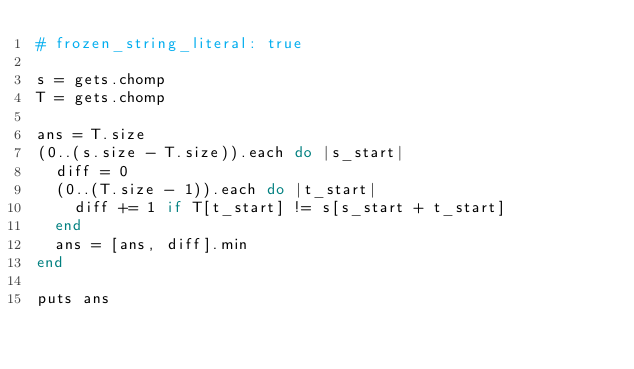Convert code to text. <code><loc_0><loc_0><loc_500><loc_500><_Ruby_># frozen_string_literal: true

s = gets.chomp
T = gets.chomp

ans = T.size
(0..(s.size - T.size)).each do |s_start|
  diff = 0
  (0..(T.size - 1)).each do |t_start|
    diff += 1 if T[t_start] != s[s_start + t_start]
  end
  ans = [ans, diff].min
end

puts ans
</code> 